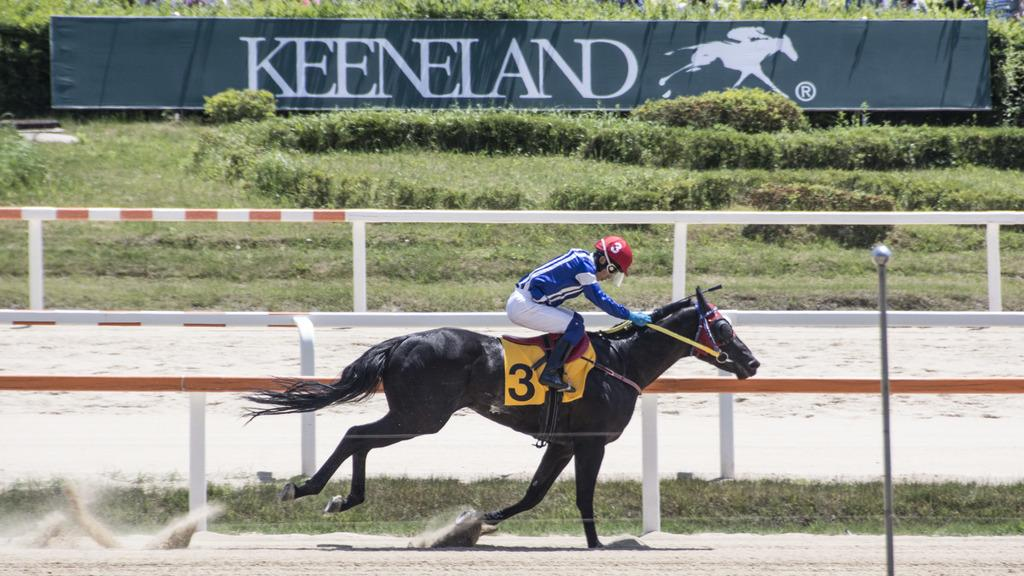What is the main subject of the image? There is a person in the image. What is the person doing in the image? The person is riding a horse. What type of surface is the horse standing on? The horse is on a sand floor. What can be seen behind the person and horse? There is a fence behind the person and horse. What type of vegetation is visible in the background? There are plants and grass in the background. What type of spark can be seen coming from the horse's hooves in the image? There is no spark coming from the horse's hooves in the image; the horse is simply standing on the sand floor. 